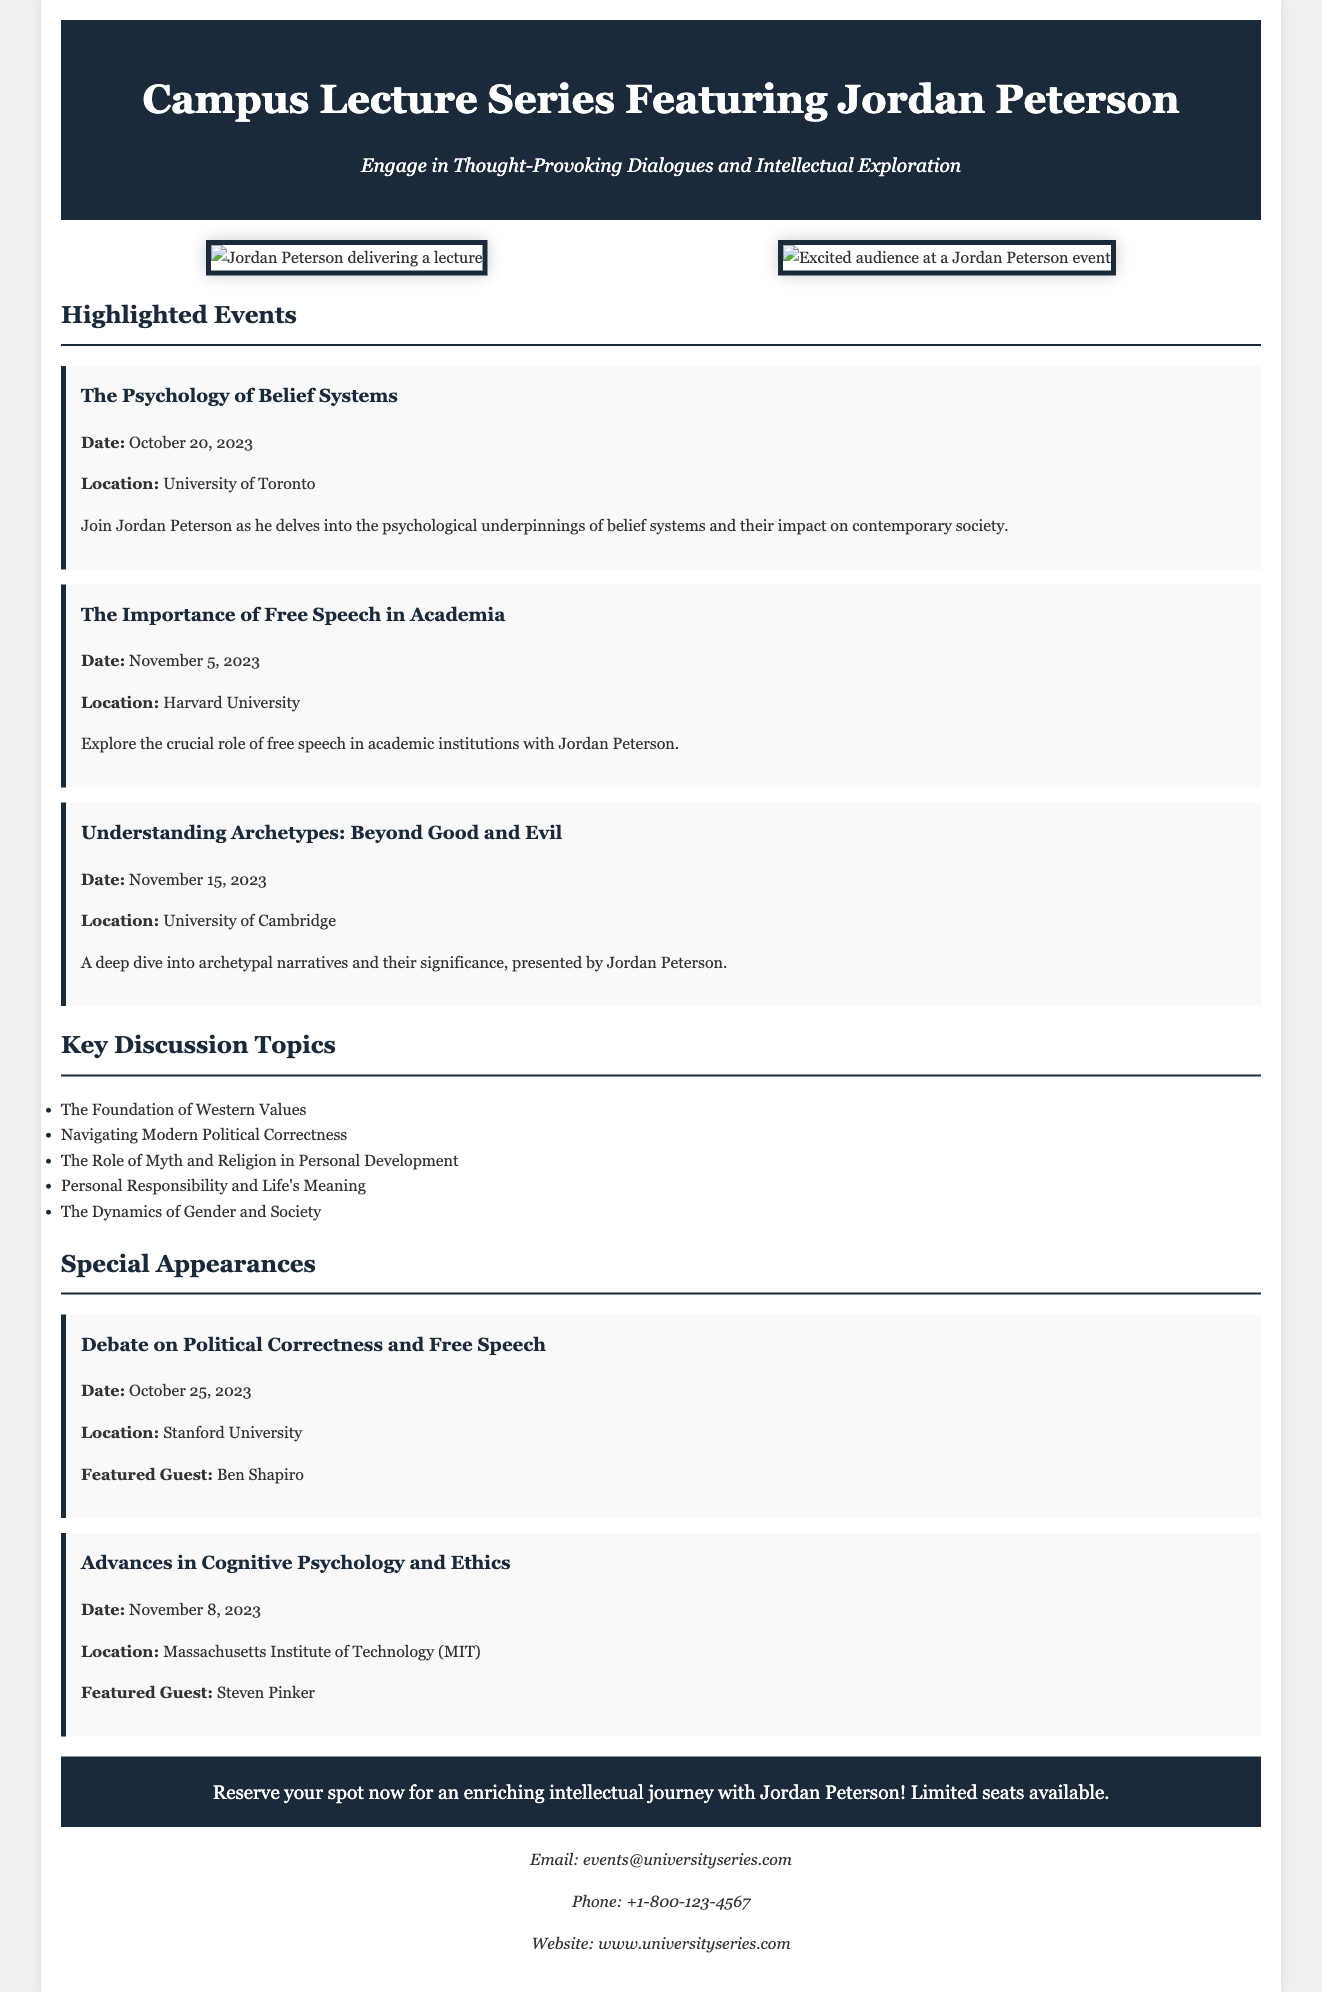What is the date of "The Psychology of Belief Systems"? The date is mentioned directly in the event details, specifically for "The Psychology of Belief Systems."
Answer: October 20, 2023 What university will host the event "Understanding Archetypes: Beyond Good and Evil"? The document states the location for "Understanding Archetypes: Beyond Good and Evil."
Answer: University of Cambridge Who is the featured guest at the debate on political correctness and free speech? The document lists Ben Shapiro as the featured guest for this event.
Answer: Ben Shapiro What is one of the key discussion topics listed in the document? The document features a list of key discussion topics that includes various subjects of discussion with Jordan Peterson.
Answer: The Foundation of Western Values What is the title of the second highlighted event? The titles of the events are clearly labeled in the event sections of the document.
Answer: The Importance of Free Speech in Academia How many highlighted events are there in total? The number of highlighted events is counted from the event section in the document.
Answer: Three What is the contact email provided in the document? The email is explicitly mentioned in the contact section of the advertisement.
Answer: events@universityseries.com What is the background color of the header? The document states the background color of the header as part of the style specifications.
Answer: #1a2a3a 